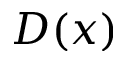Convert formula to latex. <formula><loc_0><loc_0><loc_500><loc_500>D ( x )</formula> 